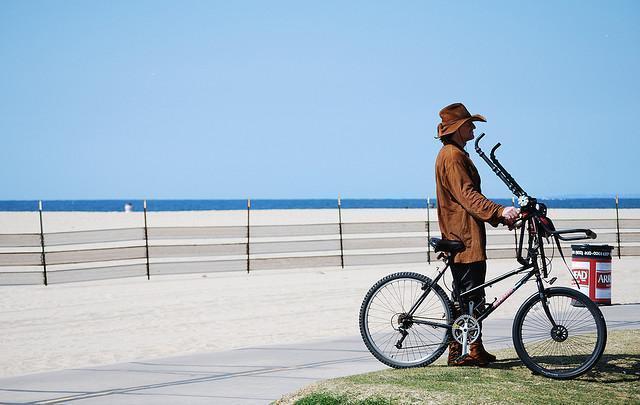How many methods of transportation are shown?
Give a very brief answer. 1. How many white horses are pulling the carriage?
Give a very brief answer. 0. 